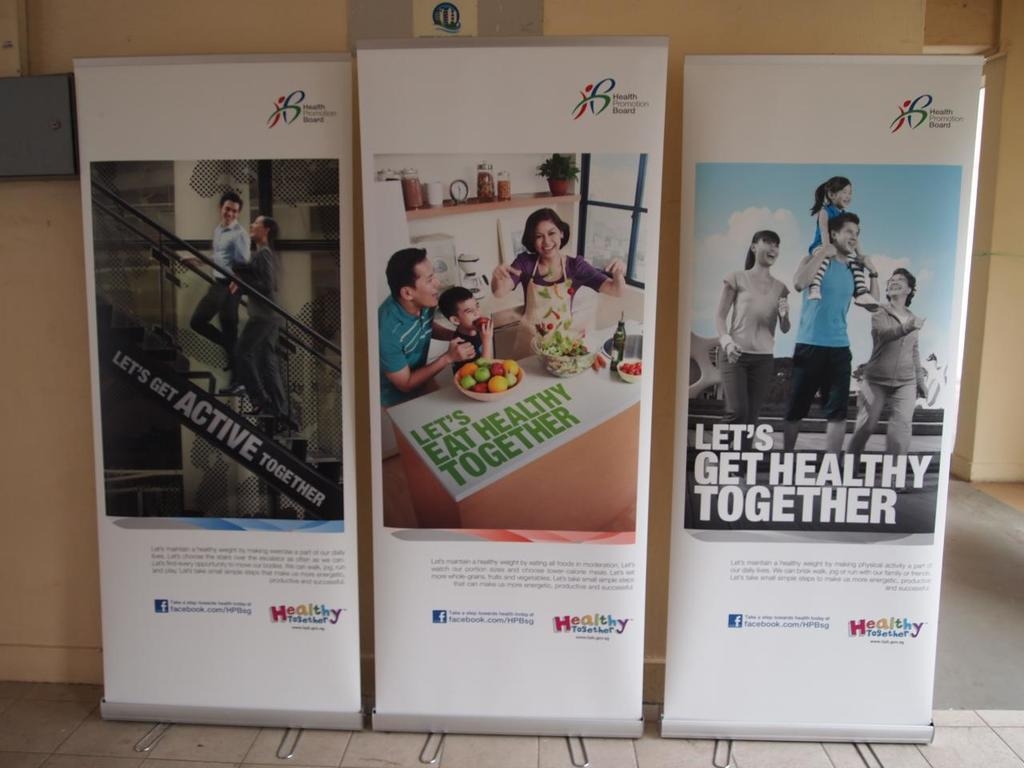Provide a one-sentence caption for the provided image. Three posters from the Health Promotion Board that say Let's get Active, Eat and get Healthy together. 